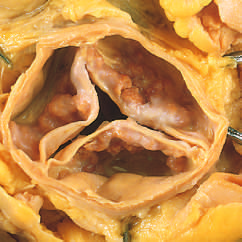re note bowing of legs as a consequence of the formation of poorly not fused, as in rheumatic aortic valve stenosis?
Answer the question using a single word or phrase. No 